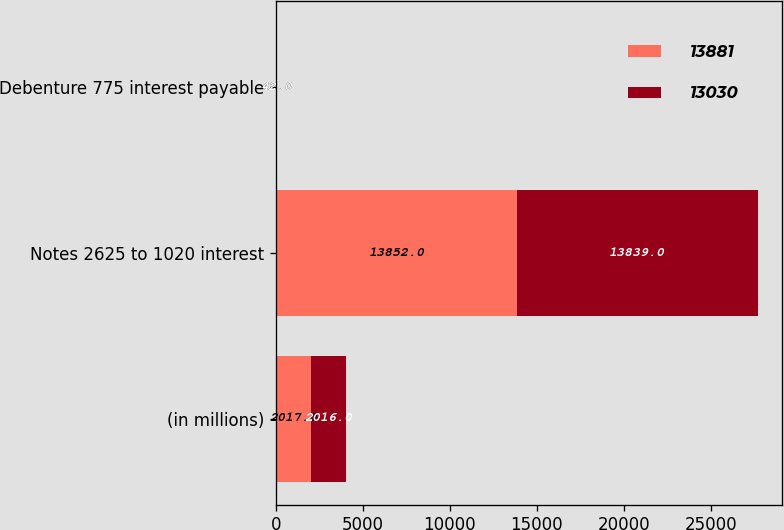Convert chart to OTSL. <chart><loc_0><loc_0><loc_500><loc_500><stacked_bar_chart><ecel><fcel>(in millions)<fcel>Notes 2625 to 1020 interest<fcel>Debenture 775 interest payable<nl><fcel>13881<fcel>2017<fcel>13852<fcel>42<nl><fcel>13030<fcel>2016<fcel>13839<fcel>42<nl></chart> 